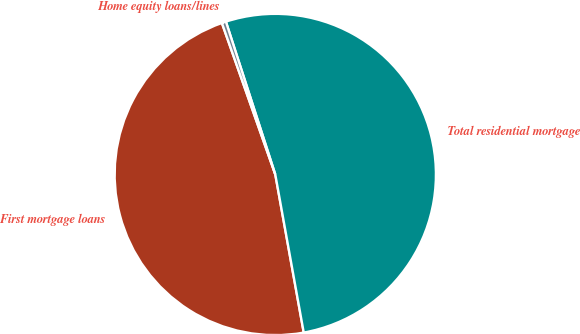Convert chart to OTSL. <chart><loc_0><loc_0><loc_500><loc_500><pie_chart><fcel>First mortgage loans<fcel>Total residential mortgage<fcel>Home equity loans/lines<nl><fcel>47.44%<fcel>52.14%<fcel>0.42%<nl></chart> 